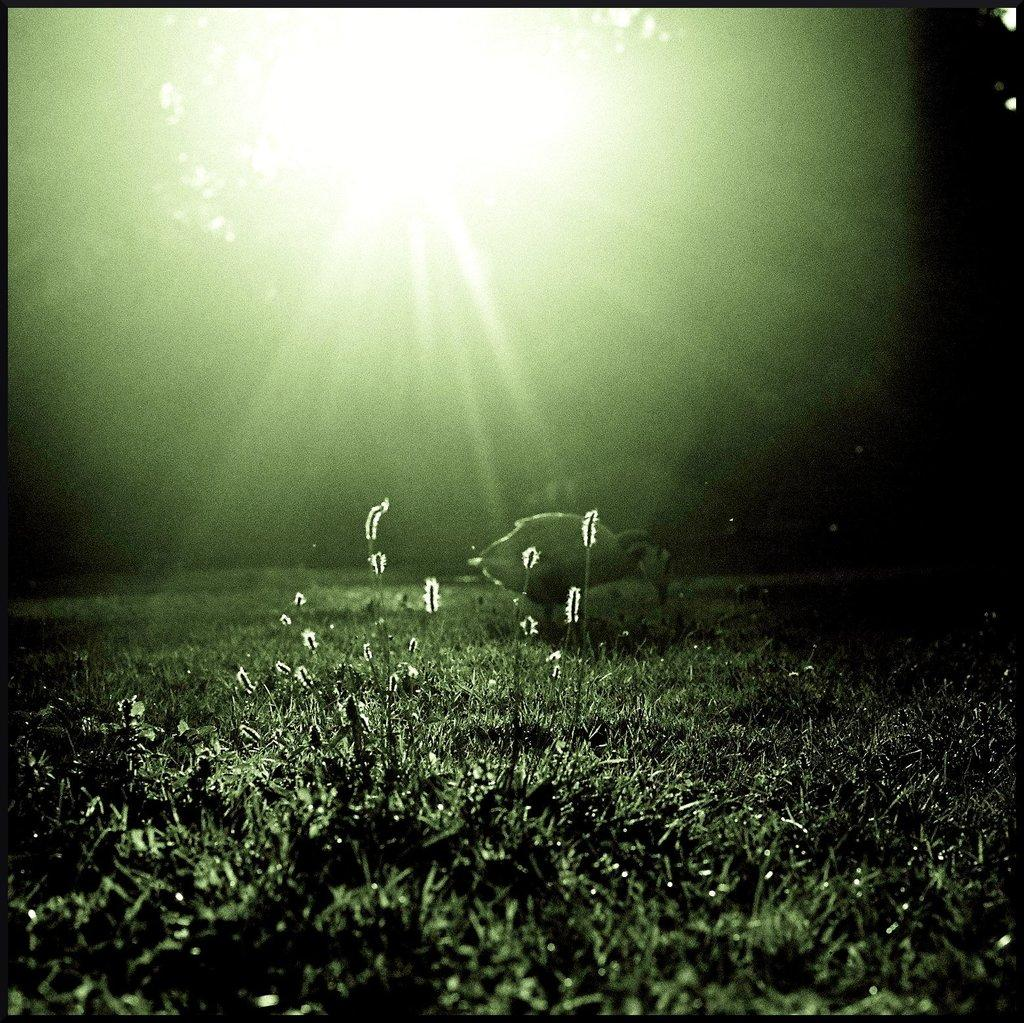What type of vegetation can be seen in the image? There is grass in the image. What natural light source is visible in the image? Sunlight is visible in the image. What is the color of the borders surrounding the image? The image has black borders on all four sides. What time of day is it in the image, and who is rubbing their hands together? The time of day cannot be determined from the image, and there is no one present to rub their hands together. 